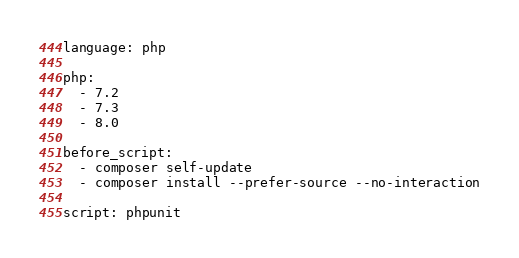<code> <loc_0><loc_0><loc_500><loc_500><_YAML_>language: php

php:
  - 7.2
  - 7.3
  - 8.0

before_script:
  - composer self-update
  - composer install --prefer-source --no-interaction

script: phpunit
</code> 